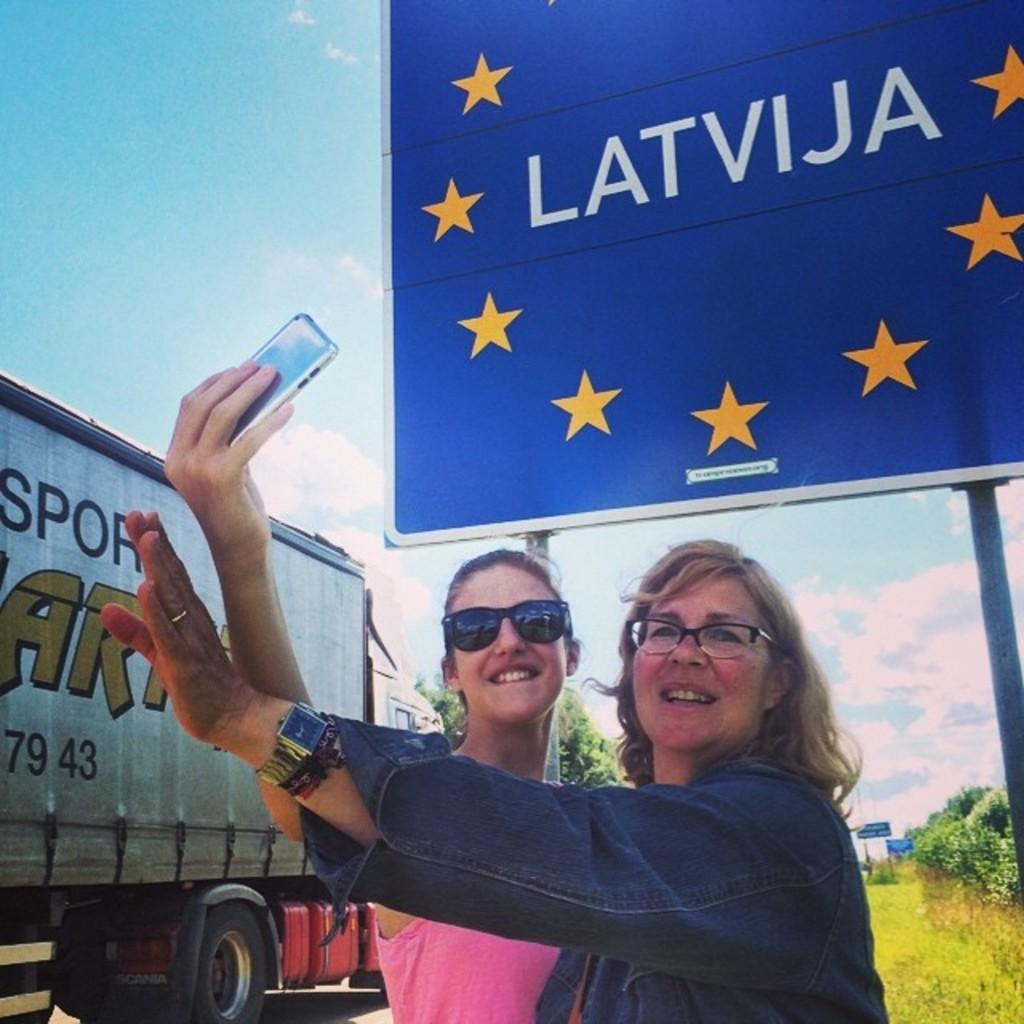How many women are in the image? There are two women in the image. What are the women doing in the image? The women are standing and laughing. What is one of the women holding in the image? One of the women is holding a mobile. What can be seen in the background of the image? There is a banner, a vehicle, a tree, and the sky visible in the background of the image. What type of destruction can be seen in the image? There is no destruction present in the image. How hot is the weather in the image? The weather cannot be determined from the image, as there is no information about temperature or climate provided. 